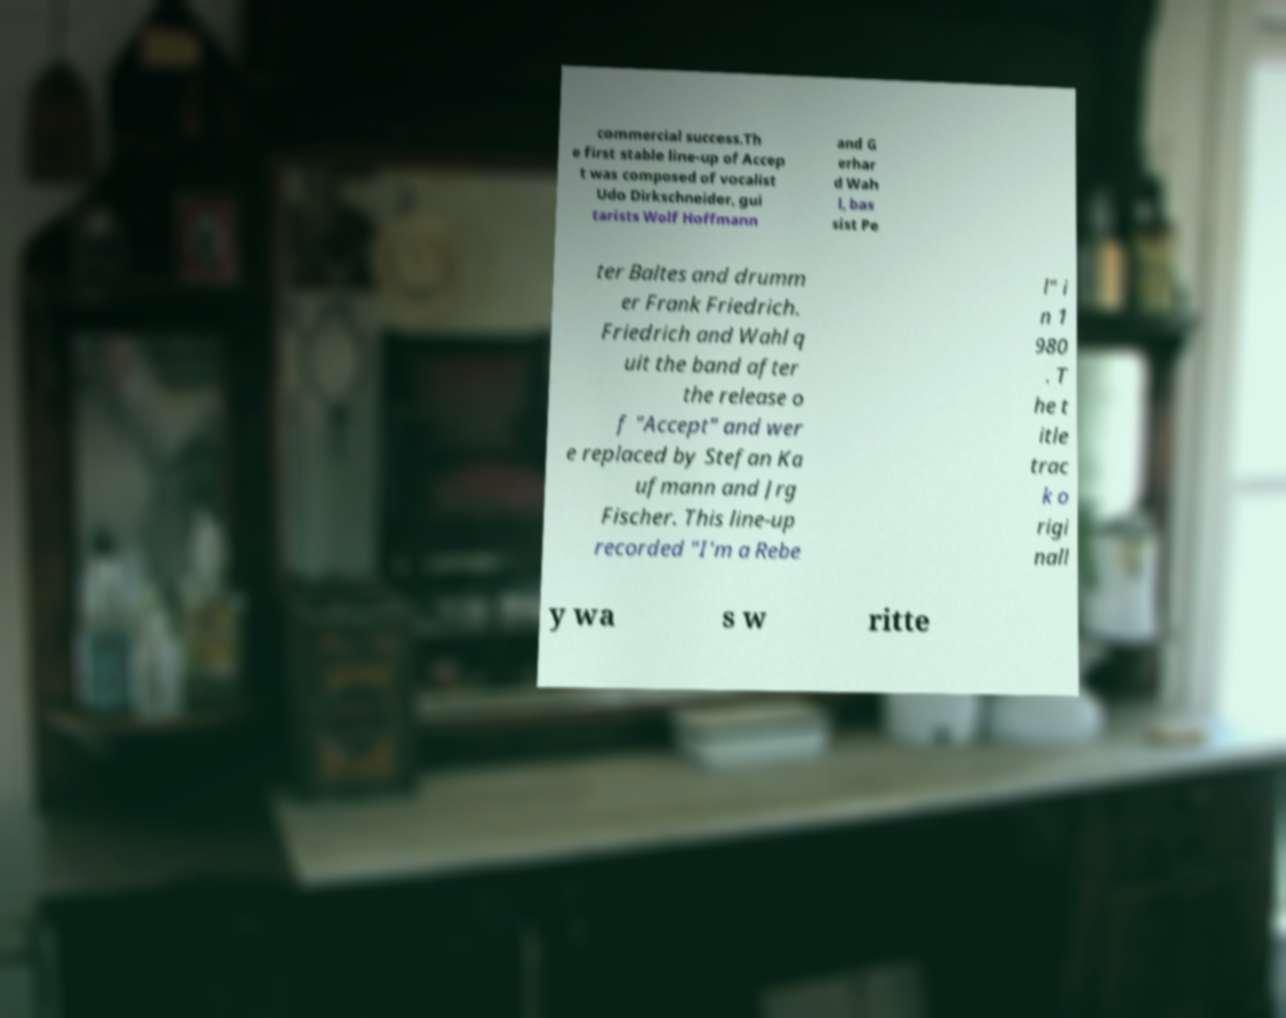I need the written content from this picture converted into text. Can you do that? commercial success.Th e first stable line-up of Accep t was composed of vocalist Udo Dirkschneider, gui tarists Wolf Hoffmann and G erhar d Wah l, bas sist Pe ter Baltes and drumm er Frank Friedrich. Friedrich and Wahl q uit the band after the release o f "Accept" and wer e replaced by Stefan Ka ufmann and Jrg Fischer. This line-up recorded "I'm a Rebe l" i n 1 980 . T he t itle trac k o rigi nall y wa s w ritte 